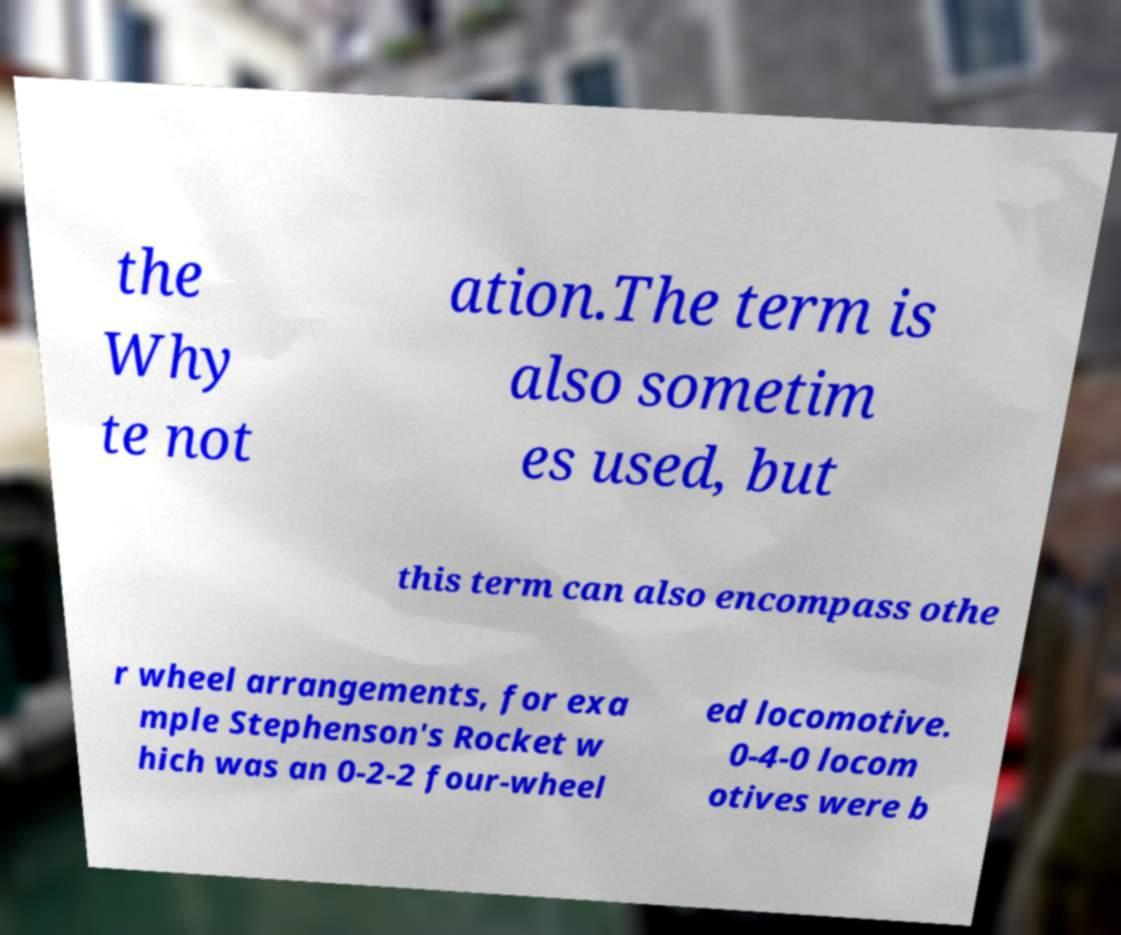What messages or text are displayed in this image? I need them in a readable, typed format. the Why te not ation.The term is also sometim es used, but this term can also encompass othe r wheel arrangements, for exa mple Stephenson's Rocket w hich was an 0-2-2 four-wheel ed locomotive. 0-4-0 locom otives were b 